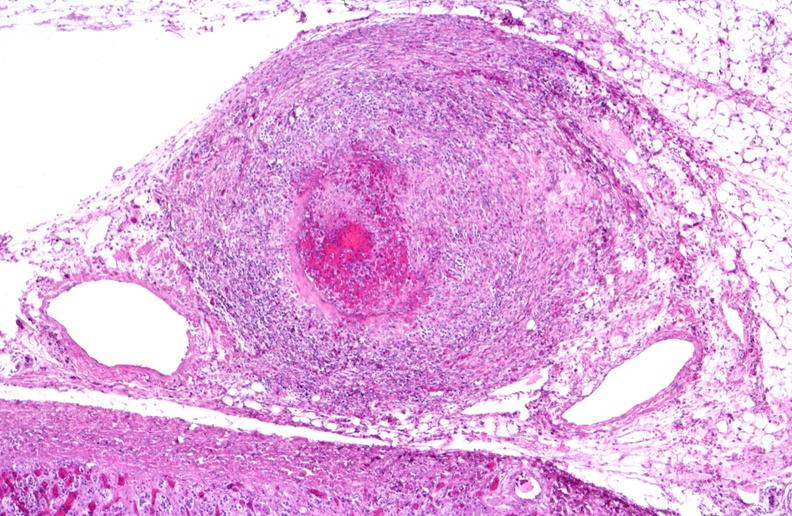does stillborn macerated show polyarteritis nodosa?
Answer the question using a single word or phrase. No 